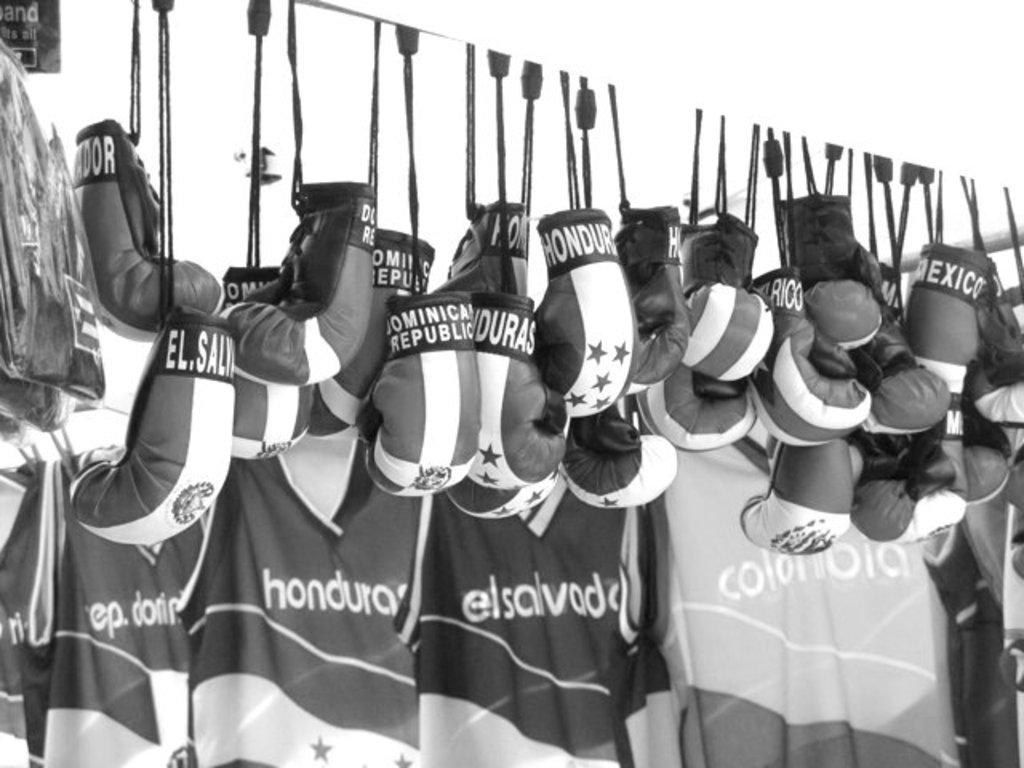<image>
Create a compact narrative representing the image presented. Numerous boxing gloves are hanging from a rope and each marked a different country like Honduras. 